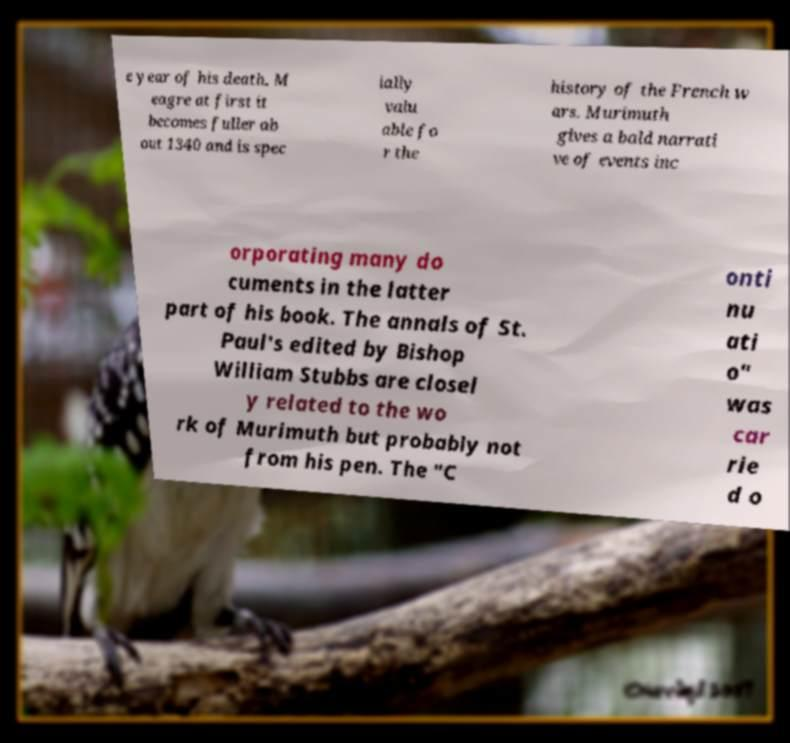Please identify and transcribe the text found in this image. e year of his death. M eagre at first it becomes fuller ab out 1340 and is spec ially valu able fo r the history of the French w ars. Murimuth gives a bald narrati ve of events inc orporating many do cuments in the latter part of his book. The annals of St. Paul's edited by Bishop William Stubbs are closel y related to the wo rk of Murimuth but probably not from his pen. The "C onti nu ati o" was car rie d o 